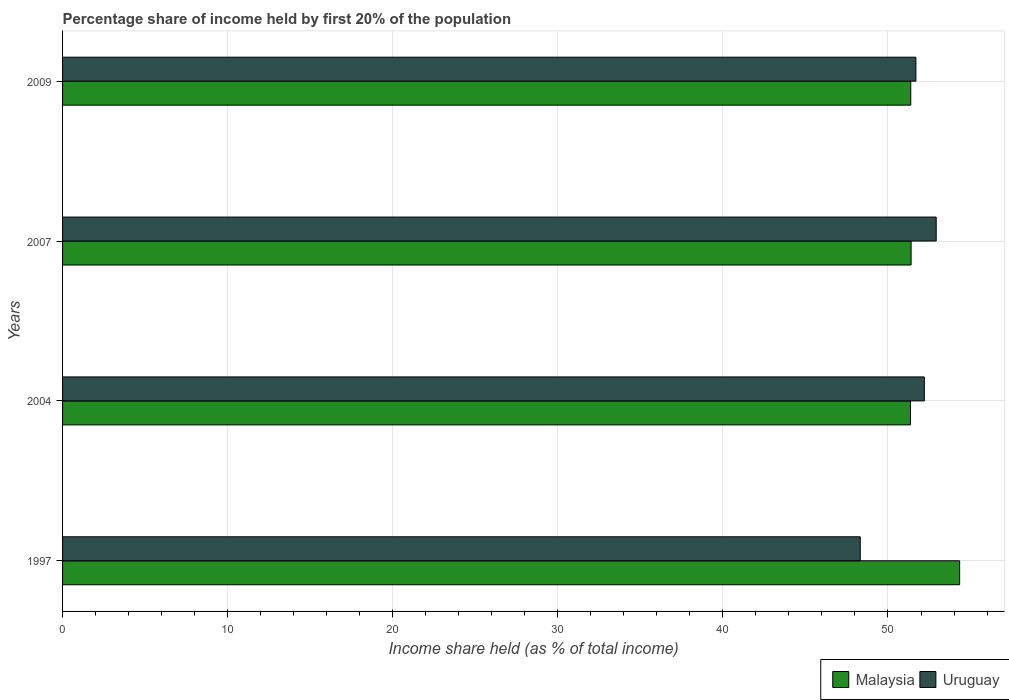How many groups of bars are there?
Provide a succinct answer. 4. Are the number of bars on each tick of the Y-axis equal?
Ensure brevity in your answer.  Yes. What is the label of the 2nd group of bars from the top?
Your response must be concise. 2007. What is the share of income held by first 20% of the population in Malaysia in 2004?
Make the answer very short. 51.36. Across all years, what is the maximum share of income held by first 20% of the population in Uruguay?
Offer a very short reply. 52.92. Across all years, what is the minimum share of income held by first 20% of the population in Malaysia?
Provide a succinct answer. 51.36. In which year was the share of income held by first 20% of the population in Uruguay maximum?
Keep it short and to the point. 2007. What is the total share of income held by first 20% of the population in Malaysia in the graph?
Make the answer very short. 208.48. What is the difference between the share of income held by first 20% of the population in Uruguay in 2004 and that in 2007?
Provide a short and direct response. -0.72. What is the difference between the share of income held by first 20% of the population in Malaysia in 2004 and the share of income held by first 20% of the population in Uruguay in 2009?
Your response must be concise. -0.33. What is the average share of income held by first 20% of the population in Malaysia per year?
Give a very brief answer. 52.12. In the year 2009, what is the difference between the share of income held by first 20% of the population in Malaysia and share of income held by first 20% of the population in Uruguay?
Offer a very short reply. -0.31. What is the ratio of the share of income held by first 20% of the population in Uruguay in 2007 to that in 2009?
Your answer should be very brief. 1.02. Is the share of income held by first 20% of the population in Uruguay in 1997 less than that in 2007?
Your response must be concise. Yes. What is the difference between the highest and the second highest share of income held by first 20% of the population in Malaysia?
Give a very brief answer. 2.94. What is the difference between the highest and the lowest share of income held by first 20% of the population in Uruguay?
Make the answer very short. 4.6. What does the 2nd bar from the top in 1997 represents?
Ensure brevity in your answer.  Malaysia. What does the 1st bar from the bottom in 2009 represents?
Offer a terse response. Malaysia. How many bars are there?
Give a very brief answer. 8. How many years are there in the graph?
Offer a very short reply. 4. What is the difference between two consecutive major ticks on the X-axis?
Your response must be concise. 10. Are the values on the major ticks of X-axis written in scientific E-notation?
Give a very brief answer. No. Does the graph contain any zero values?
Keep it short and to the point. No. How many legend labels are there?
Your answer should be compact. 2. What is the title of the graph?
Your answer should be compact. Percentage share of income held by first 20% of the population. What is the label or title of the X-axis?
Your answer should be very brief. Income share held (as % of total income). What is the label or title of the Y-axis?
Provide a succinct answer. Years. What is the Income share held (as % of total income) of Malaysia in 1997?
Your answer should be compact. 54.34. What is the Income share held (as % of total income) in Uruguay in 1997?
Offer a very short reply. 48.32. What is the Income share held (as % of total income) in Malaysia in 2004?
Provide a succinct answer. 51.36. What is the Income share held (as % of total income) in Uruguay in 2004?
Your response must be concise. 52.2. What is the Income share held (as % of total income) in Malaysia in 2007?
Offer a terse response. 51.4. What is the Income share held (as % of total income) of Uruguay in 2007?
Give a very brief answer. 52.92. What is the Income share held (as % of total income) of Malaysia in 2009?
Offer a terse response. 51.38. What is the Income share held (as % of total income) of Uruguay in 2009?
Offer a very short reply. 51.69. Across all years, what is the maximum Income share held (as % of total income) of Malaysia?
Offer a terse response. 54.34. Across all years, what is the maximum Income share held (as % of total income) in Uruguay?
Provide a succinct answer. 52.92. Across all years, what is the minimum Income share held (as % of total income) of Malaysia?
Provide a succinct answer. 51.36. Across all years, what is the minimum Income share held (as % of total income) in Uruguay?
Provide a succinct answer. 48.32. What is the total Income share held (as % of total income) in Malaysia in the graph?
Your answer should be very brief. 208.48. What is the total Income share held (as % of total income) of Uruguay in the graph?
Your answer should be compact. 205.13. What is the difference between the Income share held (as % of total income) of Malaysia in 1997 and that in 2004?
Make the answer very short. 2.98. What is the difference between the Income share held (as % of total income) in Uruguay in 1997 and that in 2004?
Your answer should be compact. -3.88. What is the difference between the Income share held (as % of total income) of Malaysia in 1997 and that in 2007?
Your answer should be compact. 2.94. What is the difference between the Income share held (as % of total income) in Uruguay in 1997 and that in 2007?
Provide a short and direct response. -4.6. What is the difference between the Income share held (as % of total income) of Malaysia in 1997 and that in 2009?
Give a very brief answer. 2.96. What is the difference between the Income share held (as % of total income) of Uruguay in 1997 and that in 2009?
Offer a very short reply. -3.37. What is the difference between the Income share held (as % of total income) of Malaysia in 2004 and that in 2007?
Ensure brevity in your answer.  -0.04. What is the difference between the Income share held (as % of total income) in Uruguay in 2004 and that in 2007?
Make the answer very short. -0.72. What is the difference between the Income share held (as % of total income) in Malaysia in 2004 and that in 2009?
Offer a very short reply. -0.02. What is the difference between the Income share held (as % of total income) in Uruguay in 2004 and that in 2009?
Give a very brief answer. 0.51. What is the difference between the Income share held (as % of total income) in Malaysia in 2007 and that in 2009?
Provide a succinct answer. 0.02. What is the difference between the Income share held (as % of total income) of Uruguay in 2007 and that in 2009?
Give a very brief answer. 1.23. What is the difference between the Income share held (as % of total income) of Malaysia in 1997 and the Income share held (as % of total income) of Uruguay in 2004?
Your answer should be compact. 2.14. What is the difference between the Income share held (as % of total income) of Malaysia in 1997 and the Income share held (as % of total income) of Uruguay in 2007?
Offer a very short reply. 1.42. What is the difference between the Income share held (as % of total income) of Malaysia in 1997 and the Income share held (as % of total income) of Uruguay in 2009?
Keep it short and to the point. 2.65. What is the difference between the Income share held (as % of total income) in Malaysia in 2004 and the Income share held (as % of total income) in Uruguay in 2007?
Offer a terse response. -1.56. What is the difference between the Income share held (as % of total income) in Malaysia in 2004 and the Income share held (as % of total income) in Uruguay in 2009?
Offer a terse response. -0.33. What is the difference between the Income share held (as % of total income) of Malaysia in 2007 and the Income share held (as % of total income) of Uruguay in 2009?
Ensure brevity in your answer.  -0.29. What is the average Income share held (as % of total income) of Malaysia per year?
Your answer should be very brief. 52.12. What is the average Income share held (as % of total income) in Uruguay per year?
Provide a succinct answer. 51.28. In the year 1997, what is the difference between the Income share held (as % of total income) of Malaysia and Income share held (as % of total income) of Uruguay?
Keep it short and to the point. 6.02. In the year 2004, what is the difference between the Income share held (as % of total income) in Malaysia and Income share held (as % of total income) in Uruguay?
Offer a terse response. -0.84. In the year 2007, what is the difference between the Income share held (as % of total income) of Malaysia and Income share held (as % of total income) of Uruguay?
Your response must be concise. -1.52. In the year 2009, what is the difference between the Income share held (as % of total income) of Malaysia and Income share held (as % of total income) of Uruguay?
Keep it short and to the point. -0.31. What is the ratio of the Income share held (as % of total income) of Malaysia in 1997 to that in 2004?
Give a very brief answer. 1.06. What is the ratio of the Income share held (as % of total income) of Uruguay in 1997 to that in 2004?
Make the answer very short. 0.93. What is the ratio of the Income share held (as % of total income) of Malaysia in 1997 to that in 2007?
Give a very brief answer. 1.06. What is the ratio of the Income share held (as % of total income) in Uruguay in 1997 to that in 2007?
Your response must be concise. 0.91. What is the ratio of the Income share held (as % of total income) of Malaysia in 1997 to that in 2009?
Offer a terse response. 1.06. What is the ratio of the Income share held (as % of total income) of Uruguay in 1997 to that in 2009?
Ensure brevity in your answer.  0.93. What is the ratio of the Income share held (as % of total income) in Uruguay in 2004 to that in 2007?
Offer a terse response. 0.99. What is the ratio of the Income share held (as % of total income) of Malaysia in 2004 to that in 2009?
Ensure brevity in your answer.  1. What is the ratio of the Income share held (as % of total income) in Uruguay in 2004 to that in 2009?
Provide a succinct answer. 1.01. What is the ratio of the Income share held (as % of total income) of Uruguay in 2007 to that in 2009?
Provide a short and direct response. 1.02. What is the difference between the highest and the second highest Income share held (as % of total income) of Malaysia?
Give a very brief answer. 2.94. What is the difference between the highest and the second highest Income share held (as % of total income) of Uruguay?
Keep it short and to the point. 0.72. What is the difference between the highest and the lowest Income share held (as % of total income) of Malaysia?
Offer a very short reply. 2.98. What is the difference between the highest and the lowest Income share held (as % of total income) of Uruguay?
Your answer should be compact. 4.6. 